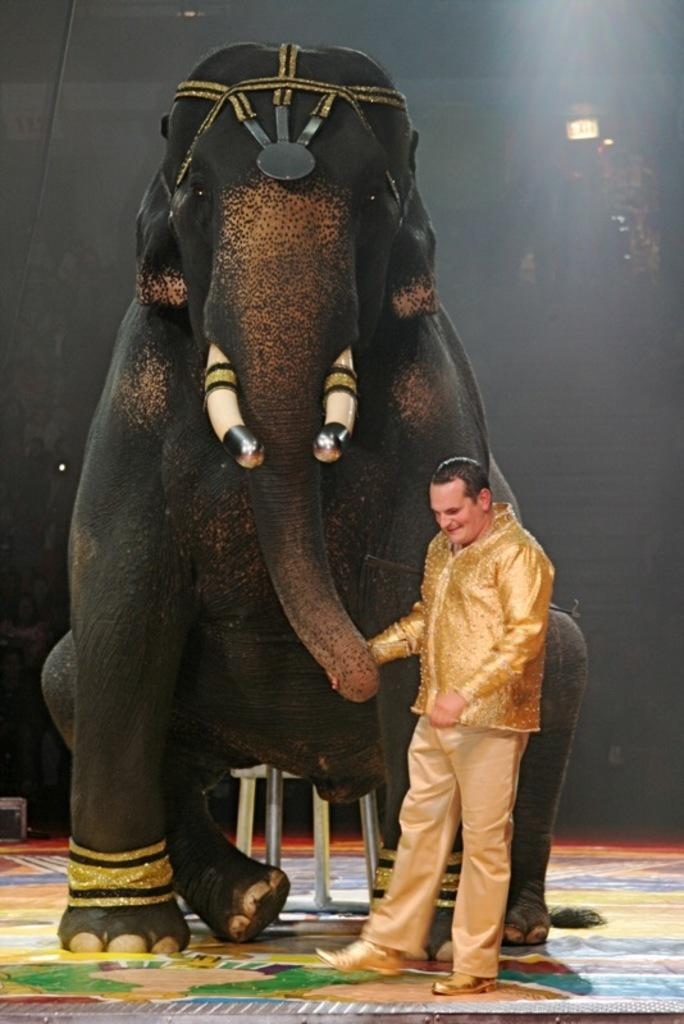What type of animal is in the picture? There is an elephant in the picture. Who else is present in the picture? There is a man in the picture. What type of bun is the elephant holding in the picture? There is no bun present in the picture; it features an elephant and a man. How many times does the man sneeze in the picture? There is no indication of the man sneezing in the picture. 